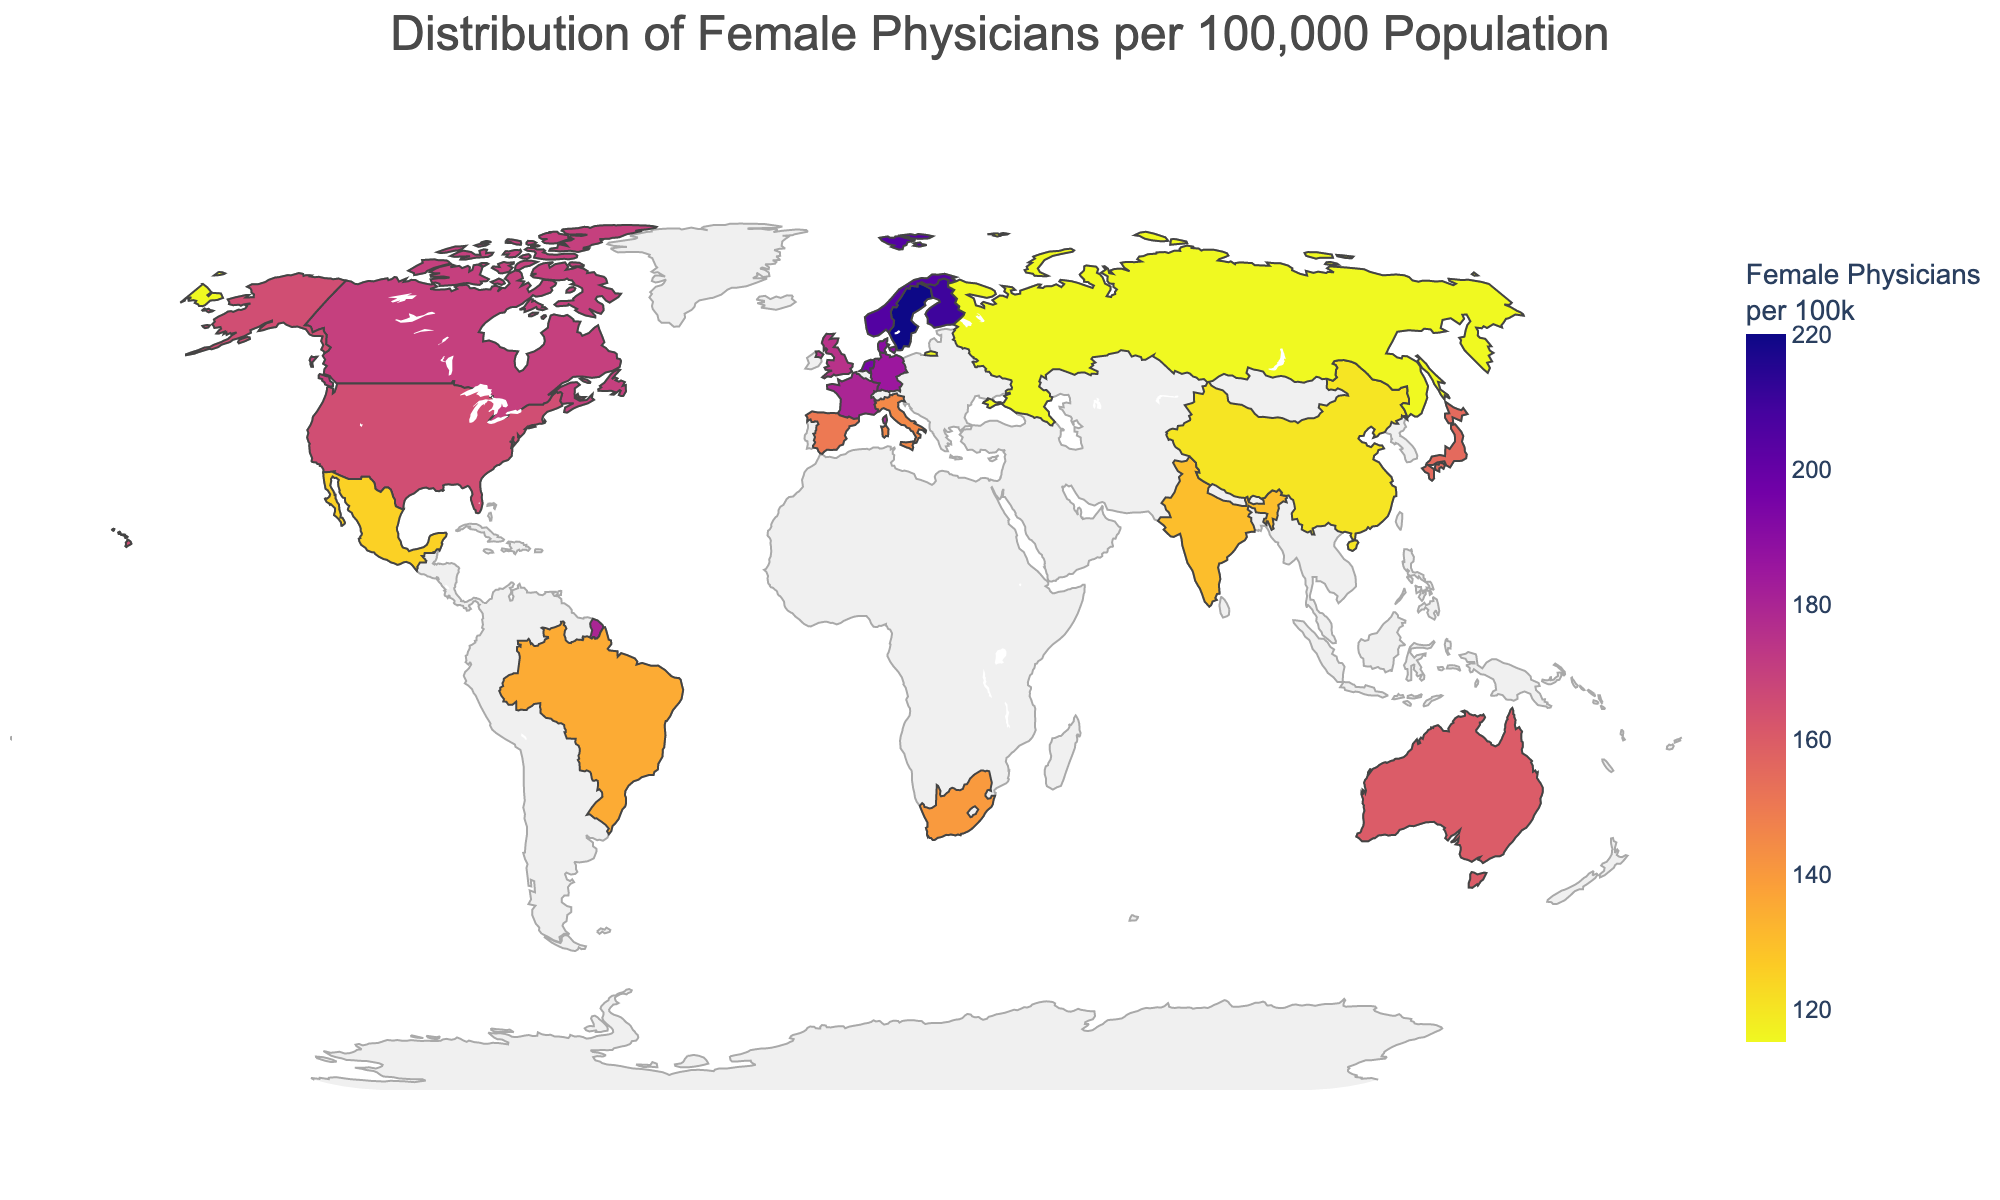Which country has the highest number of female physicians per 100,000 population? The figure shows a choropleth map colored according to the number of female physicians per capita. By observing the darkest shaded area, which represents the highest value, we can identify Sweden with 220 female physicians per 100,000 population.
Answer: Sweden What is the number of female physicians per 100,000 population in Germany? We can find Germany on the map and check the color shade corresponding to it. From the data, it corresponds to a light shade indicating 185 female physicians per 100,000 population.
Answer: 185 How many countries have more than 200 female physicians per 100,000 population? Observing the figure and the color scale, we look at the countries in the darkest color ranges. Those countries are Sweden (220), Finland (210), and Norway (205), resulting in 3 countries.
Answer: 3 Which has more female physicians per 100,000 population, Australia or Japan, and by how much? By checking the shades corresponding to Australia and Japan on the map, Australia has 160 and Japan has 155, respectively. Thus, Australia has 160 - 155 = 5 more female physicians per 100,000 population than Japan.
Answer: Australia by 5 What is the average number of female physicians per 100,000 population across the top five nations? Identify the top five nations from the data (Sweden, Finland, Norway, Netherlands, Denmark). Then, calculate the average: (220 + 210 + 205 + 195 + 190) / 5 = 204
Answer: 204 Which continent predominantly appears to have higher representation of female physicians per capita? Observing the geographic distribution on the map, Europe has several countries with higher representation (darker shades) like Sweden, Finland, Norway, Netherlands, Denmark, and Germany.
Answer: Europe What is the median value of female physicians per 100,000 population in the provided data? Order the data values and identify the middle value. The data ordered is: 115, 120, 125, 130, 135, 140, 145, 150, 155, 160, 165, 170, 175, 180, 185, 190, 195, 205, 210, 220. The median is (10th + 11th)/2 = (160 + 165)/2 = 162.5
Answer: 162.5 Are there any countries in the Southern Hemisphere with female physicians per 100,000 exceeding 150? From the data and observing the geolocation, both South Africa and Brazil in the southern hemisphere have values below 150 (140 and 135 respectively) and none exceed 150.
Answer: No Which country has the lowest number of female physicians per 100,000 population and how many? By looking at the lightest shades on the map, we find Russia with 115 female physicians per 100,000 population.
Answer: Russia, 115 What is the total number of countries with female physicians per 100,000 between 150 and 200, inclusive? From the map shades and data values, Spain (150), Italy (145), United Kingdom (175), Canada (170), Australia (160), and Netherlands (195) lie within this range. Total = 6 countries.
Answer: 6 